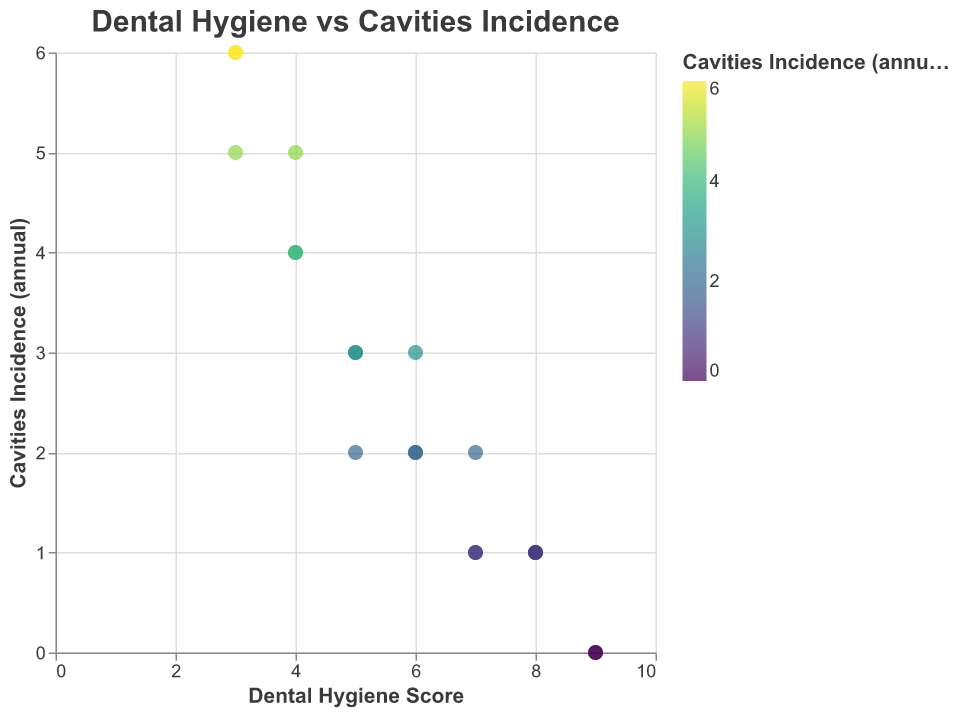What is the title of the figure? The title is located at the top center of the figure and written in a larger font. It clearly indicates the topic of the chart.
Answer: Dental Hygiene vs Cavities Incidence How many data points have a Dental Hygiene Score of 8? To find this, look at the chart and count the points on the radial axis where the value corresponds to a Dental Hygiene Score of 8.
Answer: 3 What is the Cavities Incidence for the teenager with the lowest Dental Hygiene Score? The teenager with the lowest Dental Hygiene Score (3) appears on the radial axis and their corresponding Cavities Incidence (annual) is indicated by their position on the polar chart. Look for the data point with the lowest score and the associated incidence.
Answer: 6 Compare the teenagers with the highest Dental Hygiene Score. How do their Cavities Incidences differ? The highest Dental Hygiene Score is 9, which corresponds to two teenagers. For each of these data points, examine the corresponding Cavities Incidence on the polar chart.
Answer: Both have 0 cavities What's the average Cavities Incidence for teenagers with a Dental Hygiene Score of 7? Identify all data points with a Dental Hygiene Score of 7. Sum up their Cavities Incidences and then divide by the number of data points. (2 + 1 + 1) / 3 = 1.33.
Answer: 1.33 What is the general trend between Dental Hygiene Scores and Cavities Incidences? Observe the overall distribution of data points to identify a relationship. Generally, see if higher Dental Hygiene Scores correspond to lower Cavities Incidences.
Answer: Higher scores generally lead to fewer cavities Which teenager has a Dental Hygiene Score of 6 and how many cavities do they have? Find the data points with a Dental Hygiene Score of 6. There are three such points, check their tooltips or their positioning to determine the teenager names and the corresponding Cavities Incidence.
Answer: Noah, Amelia, Isabella; 2, 2, 3 Is there any teenager with a Dental Hygiene Score of 5 and a Cavities Incidence of 2? Locate data points with a Dental Hygiene Score of 5 and check their Cavities Incidence values.
Answer: Yes, Sebastian 